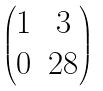<formula> <loc_0><loc_0><loc_500><loc_500>\begin{pmatrix} 1 & 3 \\ 0 & 2 8 \end{pmatrix}</formula> 